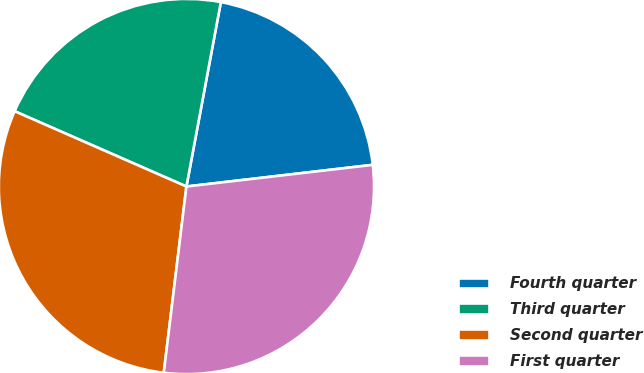Convert chart. <chart><loc_0><loc_0><loc_500><loc_500><pie_chart><fcel>Fourth quarter<fcel>Third quarter<fcel>Second quarter<fcel>First quarter<nl><fcel>20.22%<fcel>21.36%<fcel>29.65%<fcel>28.77%<nl></chart> 